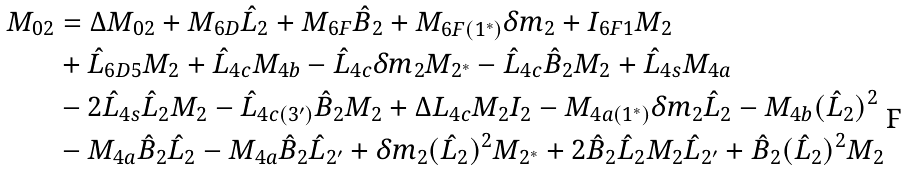<formula> <loc_0><loc_0><loc_500><loc_500>M _ { 0 2 } & = \Delta M _ { 0 2 } + M _ { 6 D } \hat { L } _ { 2 } + M _ { 6 F } \hat { B } _ { 2 } + M _ { 6 F ( 1 ^ { \ast } ) } \delta m _ { 2 } + I _ { 6 F 1 } M _ { 2 } \\ & + \hat { L } _ { 6 D 5 } M _ { 2 } + \hat { L } _ { 4 c } M _ { 4 b } - \hat { L } _ { 4 c } \delta m _ { 2 } M _ { 2 ^ { \ast } } - \hat { L } _ { 4 c } \hat { B } _ { 2 } M _ { 2 } + \hat { L } _ { 4 s } M _ { 4 a } \\ & - 2 \hat { L } _ { 4 s } \hat { L } _ { 2 } M _ { 2 } - \hat { L } _ { 4 c ( 3 ^ { \prime } ) } \hat { B } _ { 2 } M _ { 2 } + \Delta L _ { 4 c } M _ { 2 } I _ { 2 } - M _ { 4 a ( 1 ^ { \ast } ) } \delta m _ { 2 } \hat { L } _ { 2 } - M _ { 4 b } ( \hat { L } _ { 2 } ) ^ { 2 } \\ & - M _ { 4 a } \hat { B } _ { 2 } \hat { L } _ { 2 } - M _ { 4 a } \hat { B } _ { 2 } \hat { L } _ { 2 ^ { \prime } } + \delta m _ { 2 } ( \hat { L } _ { 2 } ) ^ { 2 } M _ { 2 ^ { \ast } } + 2 \hat { B } _ { 2 } \hat { L } _ { 2 } M _ { 2 } \hat { L } _ { 2 ^ { \prime } } + \hat { B } _ { 2 } ( \hat { L } _ { 2 } ) ^ { 2 } M _ { 2 }</formula> 